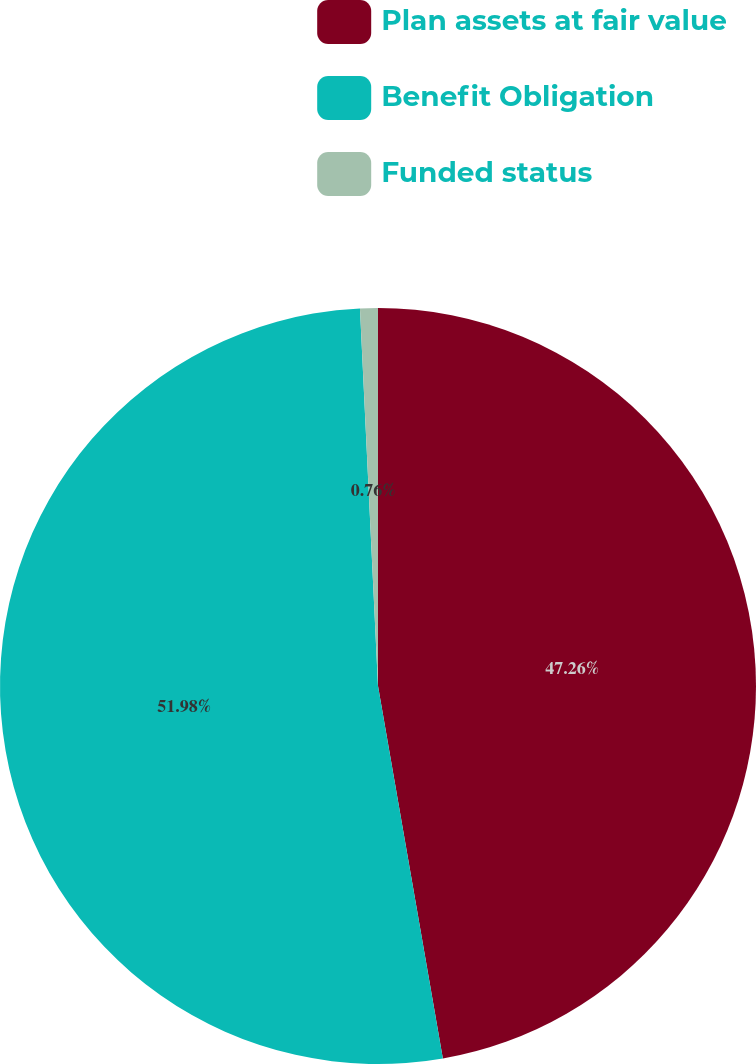Convert chart. <chart><loc_0><loc_0><loc_500><loc_500><pie_chart><fcel>Plan assets at fair value<fcel>Benefit Obligation<fcel>Funded status<nl><fcel>47.26%<fcel>51.99%<fcel>0.76%<nl></chart> 